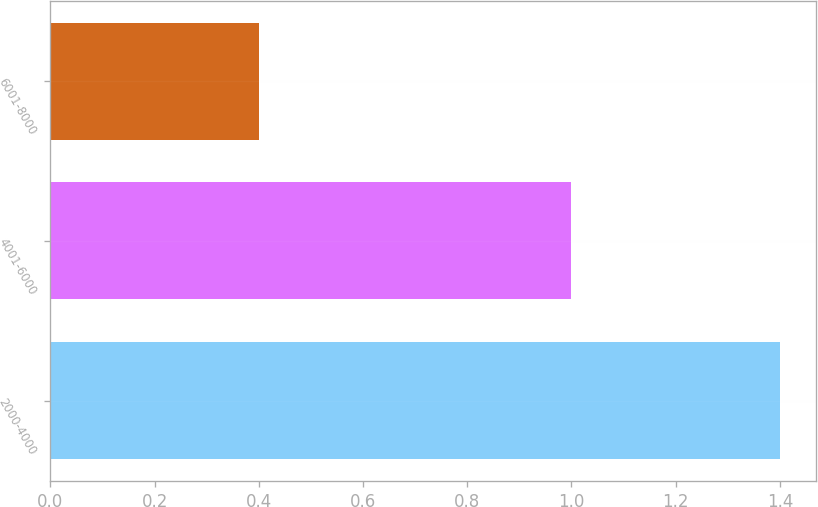Convert chart. <chart><loc_0><loc_0><loc_500><loc_500><bar_chart><fcel>2000-4000<fcel>4001-6000<fcel>6001-8000<nl><fcel>1.4<fcel>1<fcel>0.4<nl></chart> 